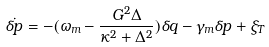<formula> <loc_0><loc_0><loc_500><loc_500>\dot { \delta p } = - ( \omega _ { m } - \frac { G ^ { 2 } \Delta } { \kappa ^ { 2 } + \Delta ^ { 2 } } ) \delta q - \gamma _ { m } \delta p + \xi _ { T }</formula> 